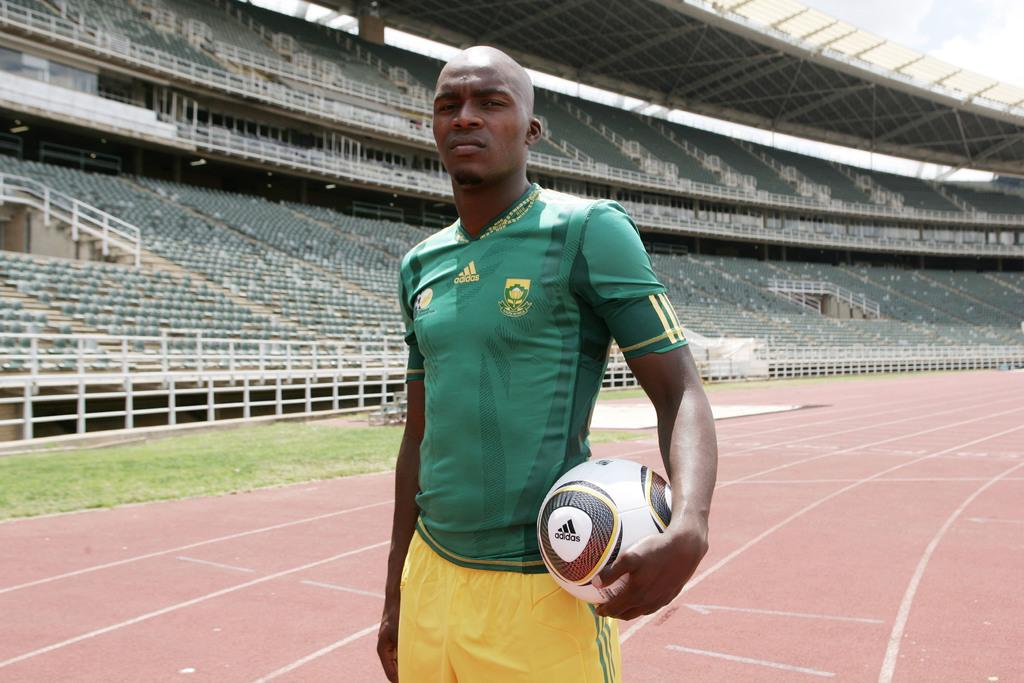Who is in the image? There is a man in the image. What is the man wearing? The man is wearing a football jersey. What is the man holding in the image? The man is holding a football. What can be seen in the background of the image? There is a stadium in the background of the image. What type of property is the man smashing in the image? There is no property being smashed in the image; the man is holding a football and there is a stadium in the background. 